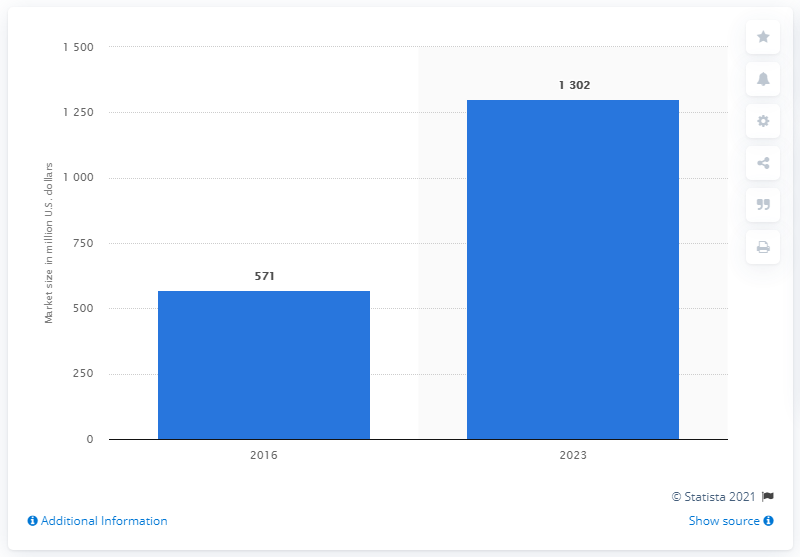Highlight a few significant elements in this photo. The market for medical carts was estimated to be approximately 1.3 billion U.S. dollars in 2016. The global market for medical carts is projected to reach $1302 million by 2023. The forecast for the market for medical carts in 2023 is expected to be strong. 